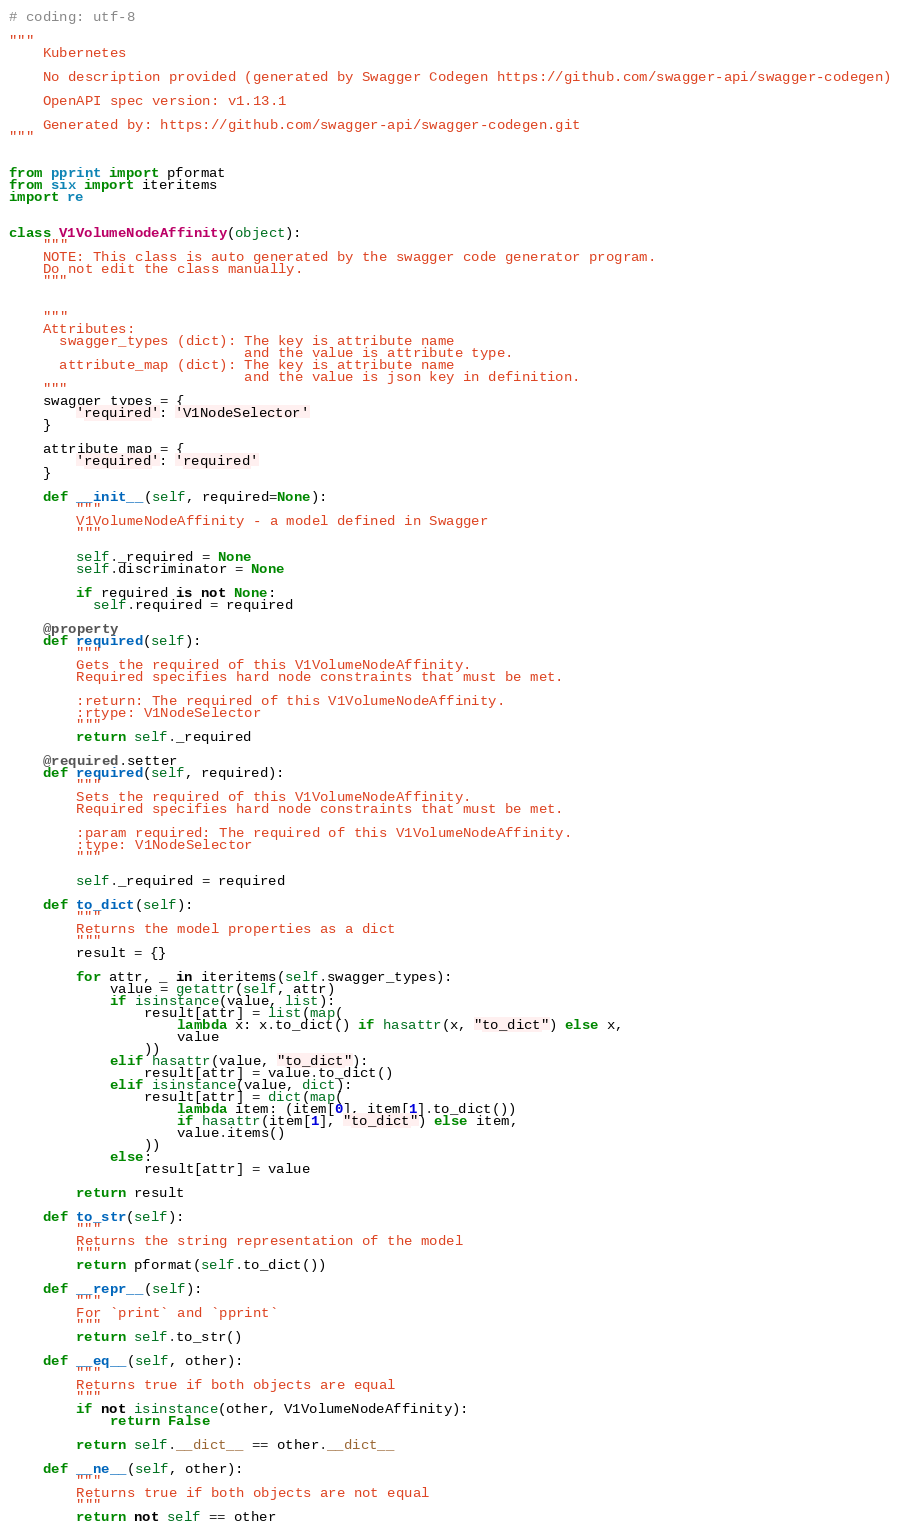Convert code to text. <code><loc_0><loc_0><loc_500><loc_500><_Python_># coding: utf-8

"""
    Kubernetes

    No description provided (generated by Swagger Codegen https://github.com/swagger-api/swagger-codegen)

    OpenAPI spec version: v1.13.1
    
    Generated by: https://github.com/swagger-api/swagger-codegen.git
"""


from pprint import pformat
from six import iteritems
import re


class V1VolumeNodeAffinity(object):
    """
    NOTE: This class is auto generated by the swagger code generator program.
    Do not edit the class manually.
    """


    """
    Attributes:
      swagger_types (dict): The key is attribute name
                            and the value is attribute type.
      attribute_map (dict): The key is attribute name
                            and the value is json key in definition.
    """
    swagger_types = {
        'required': 'V1NodeSelector'
    }

    attribute_map = {
        'required': 'required'
    }

    def __init__(self, required=None):
        """
        V1VolumeNodeAffinity - a model defined in Swagger
        """

        self._required = None
        self.discriminator = None

        if required is not None:
          self.required = required

    @property
    def required(self):
        """
        Gets the required of this V1VolumeNodeAffinity.
        Required specifies hard node constraints that must be met.

        :return: The required of this V1VolumeNodeAffinity.
        :rtype: V1NodeSelector
        """
        return self._required

    @required.setter
    def required(self, required):
        """
        Sets the required of this V1VolumeNodeAffinity.
        Required specifies hard node constraints that must be met.

        :param required: The required of this V1VolumeNodeAffinity.
        :type: V1NodeSelector
        """

        self._required = required

    def to_dict(self):
        """
        Returns the model properties as a dict
        """
        result = {}

        for attr, _ in iteritems(self.swagger_types):
            value = getattr(self, attr)
            if isinstance(value, list):
                result[attr] = list(map(
                    lambda x: x.to_dict() if hasattr(x, "to_dict") else x,
                    value
                ))
            elif hasattr(value, "to_dict"):
                result[attr] = value.to_dict()
            elif isinstance(value, dict):
                result[attr] = dict(map(
                    lambda item: (item[0], item[1].to_dict())
                    if hasattr(item[1], "to_dict") else item,
                    value.items()
                ))
            else:
                result[attr] = value

        return result

    def to_str(self):
        """
        Returns the string representation of the model
        """
        return pformat(self.to_dict())

    def __repr__(self):
        """
        For `print` and `pprint`
        """
        return self.to_str()

    def __eq__(self, other):
        """
        Returns true if both objects are equal
        """
        if not isinstance(other, V1VolumeNodeAffinity):
            return False

        return self.__dict__ == other.__dict__

    def __ne__(self, other):
        """
        Returns true if both objects are not equal
        """
        return not self == other
</code> 